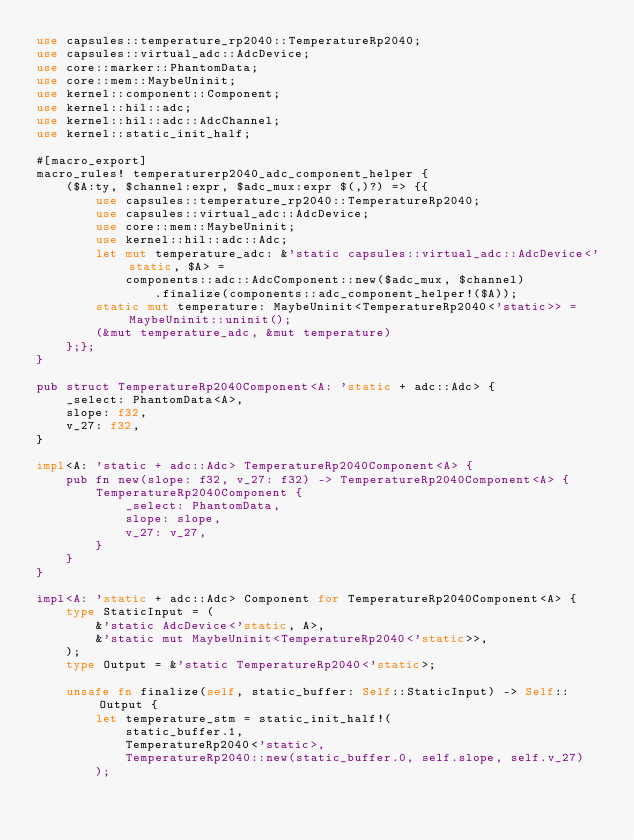Convert code to text. <code><loc_0><loc_0><loc_500><loc_500><_Rust_>use capsules::temperature_rp2040::TemperatureRp2040;
use capsules::virtual_adc::AdcDevice;
use core::marker::PhantomData;
use core::mem::MaybeUninit;
use kernel::component::Component;
use kernel::hil::adc;
use kernel::hil::adc::AdcChannel;
use kernel::static_init_half;

#[macro_export]
macro_rules! temperaturerp2040_adc_component_helper {
    ($A:ty, $channel:expr, $adc_mux:expr $(,)?) => {{
        use capsules::temperature_rp2040::TemperatureRp2040;
        use capsules::virtual_adc::AdcDevice;
        use core::mem::MaybeUninit;
        use kernel::hil::adc::Adc;
        let mut temperature_adc: &'static capsules::virtual_adc::AdcDevice<'static, $A> =
            components::adc::AdcComponent::new($adc_mux, $channel)
                .finalize(components::adc_component_helper!($A));
        static mut temperature: MaybeUninit<TemperatureRp2040<'static>> = MaybeUninit::uninit();
        (&mut temperature_adc, &mut temperature)
    };};
}

pub struct TemperatureRp2040Component<A: 'static + adc::Adc> {
    _select: PhantomData<A>,
    slope: f32,
    v_27: f32,
}

impl<A: 'static + adc::Adc> TemperatureRp2040Component<A> {
    pub fn new(slope: f32, v_27: f32) -> TemperatureRp2040Component<A> {
        TemperatureRp2040Component {
            _select: PhantomData,
            slope: slope,
            v_27: v_27,
        }
    }
}

impl<A: 'static + adc::Adc> Component for TemperatureRp2040Component<A> {
    type StaticInput = (
        &'static AdcDevice<'static, A>,
        &'static mut MaybeUninit<TemperatureRp2040<'static>>,
    );
    type Output = &'static TemperatureRp2040<'static>;

    unsafe fn finalize(self, static_buffer: Self::StaticInput) -> Self::Output {
        let temperature_stm = static_init_half!(
            static_buffer.1,
            TemperatureRp2040<'static>,
            TemperatureRp2040::new(static_buffer.0, self.slope, self.v_27)
        );
</code> 